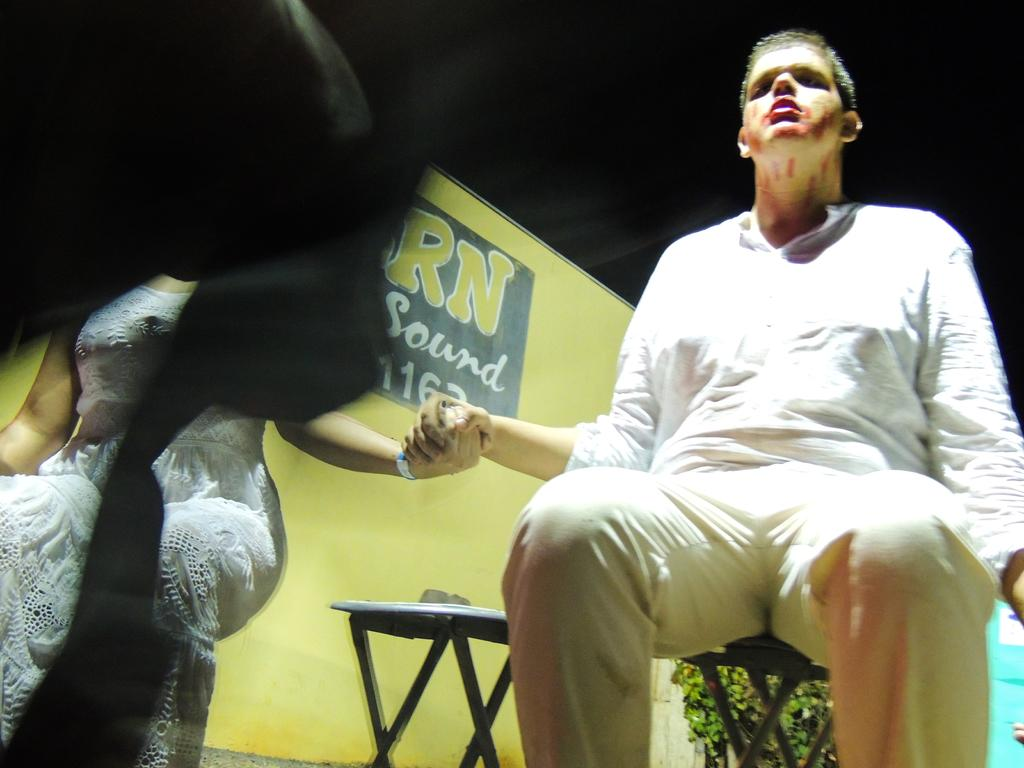How many people are sitting in the image? There are two persons sitting on chairs in the image. What can be seen on the hoarding in the image? Unfortunately, the content of the hoarding cannot be determined from the provided facts. What type of vegetation is present in the image? Leaves are present in the image. What is the color of the background in the image? The background of the image is dark. What type of pie is being served to the aunt in the image? There is no aunt or pie present in the image. How many cherries are on top of the pie in the image? There is no pie or cherries present in the image. 